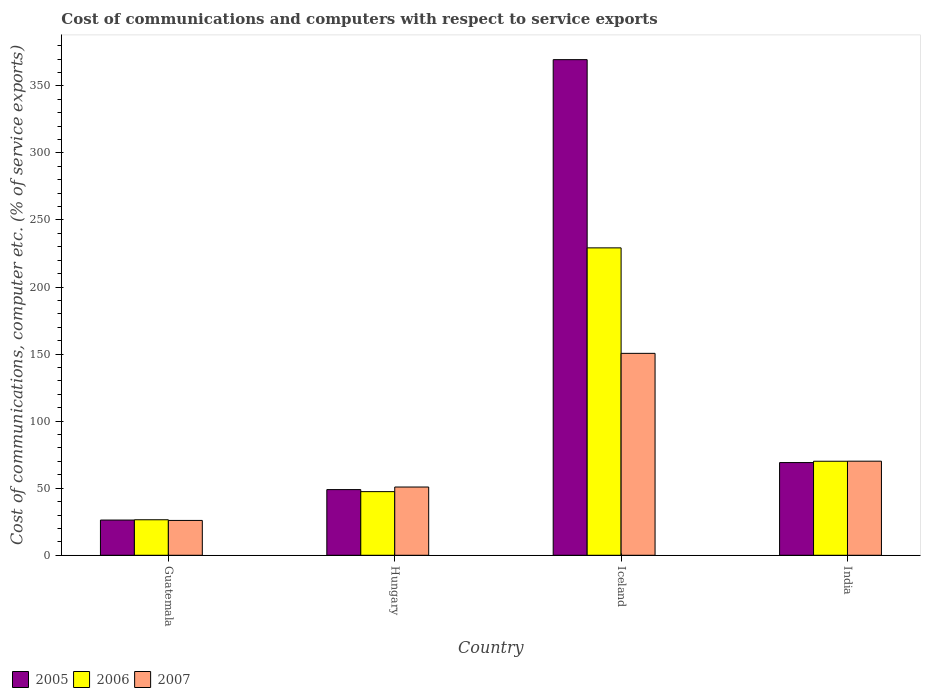How many different coloured bars are there?
Your answer should be compact. 3. How many groups of bars are there?
Give a very brief answer. 4. What is the label of the 1st group of bars from the left?
Keep it short and to the point. Guatemala. In how many cases, is the number of bars for a given country not equal to the number of legend labels?
Keep it short and to the point. 0. What is the cost of communications and computers in 2007 in India?
Your response must be concise. 70.16. Across all countries, what is the maximum cost of communications and computers in 2007?
Give a very brief answer. 150.55. Across all countries, what is the minimum cost of communications and computers in 2005?
Your answer should be very brief. 26.27. In which country was the cost of communications and computers in 2006 maximum?
Your answer should be very brief. Iceland. In which country was the cost of communications and computers in 2005 minimum?
Offer a terse response. Guatemala. What is the total cost of communications and computers in 2007 in the graph?
Give a very brief answer. 297.58. What is the difference between the cost of communications and computers in 2007 in Hungary and that in Iceland?
Provide a short and direct response. -99.66. What is the difference between the cost of communications and computers in 2007 in Iceland and the cost of communications and computers in 2006 in Guatemala?
Your answer should be very brief. 124.07. What is the average cost of communications and computers in 2007 per country?
Make the answer very short. 74.4. What is the difference between the cost of communications and computers of/in 2007 and cost of communications and computers of/in 2005 in Hungary?
Ensure brevity in your answer.  1.92. What is the ratio of the cost of communications and computers in 2007 in Guatemala to that in Iceland?
Ensure brevity in your answer.  0.17. Is the cost of communications and computers in 2007 in Hungary less than that in India?
Make the answer very short. Yes. Is the difference between the cost of communications and computers in 2007 in Guatemala and India greater than the difference between the cost of communications and computers in 2005 in Guatemala and India?
Offer a terse response. No. What is the difference between the highest and the second highest cost of communications and computers in 2006?
Provide a succinct answer. 159.1. What is the difference between the highest and the lowest cost of communications and computers in 2007?
Ensure brevity in your answer.  124.58. In how many countries, is the cost of communications and computers in 2005 greater than the average cost of communications and computers in 2005 taken over all countries?
Keep it short and to the point. 1. What does the 3rd bar from the right in Guatemala represents?
Your answer should be compact. 2005. Are all the bars in the graph horizontal?
Offer a terse response. No. Are the values on the major ticks of Y-axis written in scientific E-notation?
Keep it short and to the point. No. Does the graph contain any zero values?
Your answer should be compact. No. How many legend labels are there?
Your response must be concise. 3. How are the legend labels stacked?
Ensure brevity in your answer.  Horizontal. What is the title of the graph?
Offer a terse response. Cost of communications and computers with respect to service exports. What is the label or title of the X-axis?
Ensure brevity in your answer.  Country. What is the label or title of the Y-axis?
Provide a succinct answer. Cost of communications, computer etc. (% of service exports). What is the Cost of communications, computer etc. (% of service exports) in 2005 in Guatemala?
Keep it short and to the point. 26.27. What is the Cost of communications, computer etc. (% of service exports) in 2006 in Guatemala?
Make the answer very short. 26.49. What is the Cost of communications, computer etc. (% of service exports) in 2007 in Guatemala?
Make the answer very short. 25.98. What is the Cost of communications, computer etc. (% of service exports) of 2005 in Hungary?
Give a very brief answer. 48.97. What is the Cost of communications, computer etc. (% of service exports) of 2006 in Hungary?
Your answer should be very brief. 47.45. What is the Cost of communications, computer etc. (% of service exports) of 2007 in Hungary?
Your answer should be compact. 50.89. What is the Cost of communications, computer etc. (% of service exports) in 2005 in Iceland?
Keep it short and to the point. 369.54. What is the Cost of communications, computer etc. (% of service exports) of 2006 in Iceland?
Your answer should be very brief. 229.21. What is the Cost of communications, computer etc. (% of service exports) of 2007 in Iceland?
Give a very brief answer. 150.55. What is the Cost of communications, computer etc. (% of service exports) in 2005 in India?
Keep it short and to the point. 69.12. What is the Cost of communications, computer etc. (% of service exports) of 2006 in India?
Your answer should be compact. 70.11. What is the Cost of communications, computer etc. (% of service exports) of 2007 in India?
Your answer should be very brief. 70.16. Across all countries, what is the maximum Cost of communications, computer etc. (% of service exports) of 2005?
Make the answer very short. 369.54. Across all countries, what is the maximum Cost of communications, computer etc. (% of service exports) of 2006?
Your response must be concise. 229.21. Across all countries, what is the maximum Cost of communications, computer etc. (% of service exports) in 2007?
Your answer should be compact. 150.55. Across all countries, what is the minimum Cost of communications, computer etc. (% of service exports) in 2005?
Ensure brevity in your answer.  26.27. Across all countries, what is the minimum Cost of communications, computer etc. (% of service exports) of 2006?
Provide a succinct answer. 26.49. Across all countries, what is the minimum Cost of communications, computer etc. (% of service exports) of 2007?
Make the answer very short. 25.98. What is the total Cost of communications, computer etc. (% of service exports) of 2005 in the graph?
Offer a very short reply. 513.89. What is the total Cost of communications, computer etc. (% of service exports) of 2006 in the graph?
Offer a very short reply. 373.26. What is the total Cost of communications, computer etc. (% of service exports) of 2007 in the graph?
Keep it short and to the point. 297.58. What is the difference between the Cost of communications, computer etc. (% of service exports) of 2005 in Guatemala and that in Hungary?
Your answer should be very brief. -22.7. What is the difference between the Cost of communications, computer etc. (% of service exports) in 2006 in Guatemala and that in Hungary?
Keep it short and to the point. -20.97. What is the difference between the Cost of communications, computer etc. (% of service exports) in 2007 in Guatemala and that in Hungary?
Offer a very short reply. -24.91. What is the difference between the Cost of communications, computer etc. (% of service exports) of 2005 in Guatemala and that in Iceland?
Offer a terse response. -343.28. What is the difference between the Cost of communications, computer etc. (% of service exports) in 2006 in Guatemala and that in Iceland?
Offer a very short reply. -202.72. What is the difference between the Cost of communications, computer etc. (% of service exports) of 2007 in Guatemala and that in Iceland?
Your response must be concise. -124.58. What is the difference between the Cost of communications, computer etc. (% of service exports) in 2005 in Guatemala and that in India?
Provide a short and direct response. -42.85. What is the difference between the Cost of communications, computer etc. (% of service exports) in 2006 in Guatemala and that in India?
Provide a short and direct response. -43.62. What is the difference between the Cost of communications, computer etc. (% of service exports) in 2007 in Guatemala and that in India?
Make the answer very short. -44.19. What is the difference between the Cost of communications, computer etc. (% of service exports) of 2005 in Hungary and that in Iceland?
Make the answer very short. -320.58. What is the difference between the Cost of communications, computer etc. (% of service exports) of 2006 in Hungary and that in Iceland?
Ensure brevity in your answer.  -181.76. What is the difference between the Cost of communications, computer etc. (% of service exports) in 2007 in Hungary and that in Iceland?
Provide a succinct answer. -99.66. What is the difference between the Cost of communications, computer etc. (% of service exports) in 2005 in Hungary and that in India?
Keep it short and to the point. -20.15. What is the difference between the Cost of communications, computer etc. (% of service exports) of 2006 in Hungary and that in India?
Your answer should be very brief. -22.66. What is the difference between the Cost of communications, computer etc. (% of service exports) of 2007 in Hungary and that in India?
Offer a very short reply. -19.27. What is the difference between the Cost of communications, computer etc. (% of service exports) in 2005 in Iceland and that in India?
Make the answer very short. 300.42. What is the difference between the Cost of communications, computer etc. (% of service exports) in 2006 in Iceland and that in India?
Provide a short and direct response. 159.1. What is the difference between the Cost of communications, computer etc. (% of service exports) in 2007 in Iceland and that in India?
Make the answer very short. 80.39. What is the difference between the Cost of communications, computer etc. (% of service exports) of 2005 in Guatemala and the Cost of communications, computer etc. (% of service exports) of 2006 in Hungary?
Offer a terse response. -21.19. What is the difference between the Cost of communications, computer etc. (% of service exports) in 2005 in Guatemala and the Cost of communications, computer etc. (% of service exports) in 2007 in Hungary?
Ensure brevity in your answer.  -24.62. What is the difference between the Cost of communications, computer etc. (% of service exports) of 2006 in Guatemala and the Cost of communications, computer etc. (% of service exports) of 2007 in Hungary?
Give a very brief answer. -24.4. What is the difference between the Cost of communications, computer etc. (% of service exports) of 2005 in Guatemala and the Cost of communications, computer etc. (% of service exports) of 2006 in Iceland?
Ensure brevity in your answer.  -202.95. What is the difference between the Cost of communications, computer etc. (% of service exports) of 2005 in Guatemala and the Cost of communications, computer etc. (% of service exports) of 2007 in Iceland?
Keep it short and to the point. -124.29. What is the difference between the Cost of communications, computer etc. (% of service exports) of 2006 in Guatemala and the Cost of communications, computer etc. (% of service exports) of 2007 in Iceland?
Your answer should be compact. -124.07. What is the difference between the Cost of communications, computer etc. (% of service exports) in 2005 in Guatemala and the Cost of communications, computer etc. (% of service exports) in 2006 in India?
Your answer should be very brief. -43.84. What is the difference between the Cost of communications, computer etc. (% of service exports) in 2005 in Guatemala and the Cost of communications, computer etc. (% of service exports) in 2007 in India?
Offer a very short reply. -43.9. What is the difference between the Cost of communications, computer etc. (% of service exports) of 2006 in Guatemala and the Cost of communications, computer etc. (% of service exports) of 2007 in India?
Provide a short and direct response. -43.68. What is the difference between the Cost of communications, computer etc. (% of service exports) of 2005 in Hungary and the Cost of communications, computer etc. (% of service exports) of 2006 in Iceland?
Your answer should be very brief. -180.25. What is the difference between the Cost of communications, computer etc. (% of service exports) of 2005 in Hungary and the Cost of communications, computer etc. (% of service exports) of 2007 in Iceland?
Your answer should be compact. -101.59. What is the difference between the Cost of communications, computer etc. (% of service exports) of 2006 in Hungary and the Cost of communications, computer etc. (% of service exports) of 2007 in Iceland?
Your response must be concise. -103.1. What is the difference between the Cost of communications, computer etc. (% of service exports) of 2005 in Hungary and the Cost of communications, computer etc. (% of service exports) of 2006 in India?
Provide a succinct answer. -21.14. What is the difference between the Cost of communications, computer etc. (% of service exports) of 2005 in Hungary and the Cost of communications, computer etc. (% of service exports) of 2007 in India?
Ensure brevity in your answer.  -21.2. What is the difference between the Cost of communications, computer etc. (% of service exports) of 2006 in Hungary and the Cost of communications, computer etc. (% of service exports) of 2007 in India?
Your answer should be very brief. -22.71. What is the difference between the Cost of communications, computer etc. (% of service exports) of 2005 in Iceland and the Cost of communications, computer etc. (% of service exports) of 2006 in India?
Give a very brief answer. 299.43. What is the difference between the Cost of communications, computer etc. (% of service exports) in 2005 in Iceland and the Cost of communications, computer etc. (% of service exports) in 2007 in India?
Offer a terse response. 299.38. What is the difference between the Cost of communications, computer etc. (% of service exports) of 2006 in Iceland and the Cost of communications, computer etc. (% of service exports) of 2007 in India?
Your answer should be compact. 159.05. What is the average Cost of communications, computer etc. (% of service exports) of 2005 per country?
Ensure brevity in your answer.  128.47. What is the average Cost of communications, computer etc. (% of service exports) in 2006 per country?
Offer a terse response. 93.32. What is the average Cost of communications, computer etc. (% of service exports) of 2007 per country?
Offer a terse response. 74.4. What is the difference between the Cost of communications, computer etc. (% of service exports) in 2005 and Cost of communications, computer etc. (% of service exports) in 2006 in Guatemala?
Offer a terse response. -0.22. What is the difference between the Cost of communications, computer etc. (% of service exports) of 2005 and Cost of communications, computer etc. (% of service exports) of 2007 in Guatemala?
Offer a very short reply. 0.29. What is the difference between the Cost of communications, computer etc. (% of service exports) in 2006 and Cost of communications, computer etc. (% of service exports) in 2007 in Guatemala?
Make the answer very short. 0.51. What is the difference between the Cost of communications, computer etc. (% of service exports) in 2005 and Cost of communications, computer etc. (% of service exports) in 2006 in Hungary?
Provide a short and direct response. 1.51. What is the difference between the Cost of communications, computer etc. (% of service exports) of 2005 and Cost of communications, computer etc. (% of service exports) of 2007 in Hungary?
Provide a short and direct response. -1.92. What is the difference between the Cost of communications, computer etc. (% of service exports) in 2006 and Cost of communications, computer etc. (% of service exports) in 2007 in Hungary?
Keep it short and to the point. -3.44. What is the difference between the Cost of communications, computer etc. (% of service exports) of 2005 and Cost of communications, computer etc. (% of service exports) of 2006 in Iceland?
Make the answer very short. 140.33. What is the difference between the Cost of communications, computer etc. (% of service exports) of 2005 and Cost of communications, computer etc. (% of service exports) of 2007 in Iceland?
Ensure brevity in your answer.  218.99. What is the difference between the Cost of communications, computer etc. (% of service exports) in 2006 and Cost of communications, computer etc. (% of service exports) in 2007 in Iceland?
Make the answer very short. 78.66. What is the difference between the Cost of communications, computer etc. (% of service exports) of 2005 and Cost of communications, computer etc. (% of service exports) of 2006 in India?
Keep it short and to the point. -0.99. What is the difference between the Cost of communications, computer etc. (% of service exports) in 2005 and Cost of communications, computer etc. (% of service exports) in 2007 in India?
Give a very brief answer. -1.05. What is the difference between the Cost of communications, computer etc. (% of service exports) in 2006 and Cost of communications, computer etc. (% of service exports) in 2007 in India?
Ensure brevity in your answer.  -0.05. What is the ratio of the Cost of communications, computer etc. (% of service exports) in 2005 in Guatemala to that in Hungary?
Ensure brevity in your answer.  0.54. What is the ratio of the Cost of communications, computer etc. (% of service exports) in 2006 in Guatemala to that in Hungary?
Offer a very short reply. 0.56. What is the ratio of the Cost of communications, computer etc. (% of service exports) in 2007 in Guatemala to that in Hungary?
Your answer should be compact. 0.51. What is the ratio of the Cost of communications, computer etc. (% of service exports) of 2005 in Guatemala to that in Iceland?
Give a very brief answer. 0.07. What is the ratio of the Cost of communications, computer etc. (% of service exports) in 2006 in Guatemala to that in Iceland?
Give a very brief answer. 0.12. What is the ratio of the Cost of communications, computer etc. (% of service exports) of 2007 in Guatemala to that in Iceland?
Your answer should be very brief. 0.17. What is the ratio of the Cost of communications, computer etc. (% of service exports) of 2005 in Guatemala to that in India?
Your answer should be very brief. 0.38. What is the ratio of the Cost of communications, computer etc. (% of service exports) of 2006 in Guatemala to that in India?
Ensure brevity in your answer.  0.38. What is the ratio of the Cost of communications, computer etc. (% of service exports) in 2007 in Guatemala to that in India?
Your answer should be compact. 0.37. What is the ratio of the Cost of communications, computer etc. (% of service exports) of 2005 in Hungary to that in Iceland?
Provide a short and direct response. 0.13. What is the ratio of the Cost of communications, computer etc. (% of service exports) of 2006 in Hungary to that in Iceland?
Make the answer very short. 0.21. What is the ratio of the Cost of communications, computer etc. (% of service exports) of 2007 in Hungary to that in Iceland?
Your answer should be compact. 0.34. What is the ratio of the Cost of communications, computer etc. (% of service exports) of 2005 in Hungary to that in India?
Provide a short and direct response. 0.71. What is the ratio of the Cost of communications, computer etc. (% of service exports) in 2006 in Hungary to that in India?
Provide a succinct answer. 0.68. What is the ratio of the Cost of communications, computer etc. (% of service exports) of 2007 in Hungary to that in India?
Keep it short and to the point. 0.73. What is the ratio of the Cost of communications, computer etc. (% of service exports) of 2005 in Iceland to that in India?
Your answer should be very brief. 5.35. What is the ratio of the Cost of communications, computer etc. (% of service exports) in 2006 in Iceland to that in India?
Give a very brief answer. 3.27. What is the ratio of the Cost of communications, computer etc. (% of service exports) in 2007 in Iceland to that in India?
Ensure brevity in your answer.  2.15. What is the difference between the highest and the second highest Cost of communications, computer etc. (% of service exports) of 2005?
Keep it short and to the point. 300.42. What is the difference between the highest and the second highest Cost of communications, computer etc. (% of service exports) in 2006?
Offer a very short reply. 159.1. What is the difference between the highest and the second highest Cost of communications, computer etc. (% of service exports) of 2007?
Provide a short and direct response. 80.39. What is the difference between the highest and the lowest Cost of communications, computer etc. (% of service exports) of 2005?
Offer a very short reply. 343.28. What is the difference between the highest and the lowest Cost of communications, computer etc. (% of service exports) in 2006?
Your answer should be very brief. 202.72. What is the difference between the highest and the lowest Cost of communications, computer etc. (% of service exports) in 2007?
Make the answer very short. 124.58. 